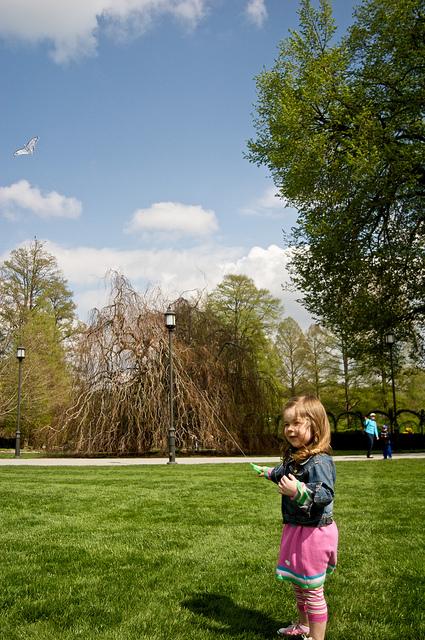What is the gender of the little kid?
Be succinct. Girl. Is this child eating?
Short answer required. No. Are there balloons in the background?
Quick response, please. No. How many people are in the photo?
Concise answer only. 3. What color is her dress?
Quick response, please. Pink. What color is her socks?
Keep it brief. White. Is the kite high in the air?
Keep it brief. Yes. What is the girl doing with her hands?
Be succinct. Flying kite. How many people are there?
Quick response, please. 3. Has she worn shades?
Short answer required. No. Is all the grass cut?
Quick response, please. Yes. What is she doing?
Short answer required. Flying kite. 